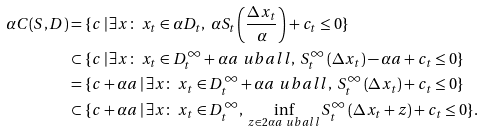<formula> <loc_0><loc_0><loc_500><loc_500>\alpha C ( S , D ) & = \{ c \, | \, \exists x \colon \ x _ { t } \in \alpha D _ { t } , \ \alpha S _ { t } \left ( \frac { \Delta x _ { t } } { \alpha } \right ) + c _ { t } \leq 0 \} \\ & \subset \{ c \, | \, \exists x \colon \ x _ { t } \in D ^ { \infty } _ { t } + \alpha a \ u b a l l , \ S ^ { \infty } _ { t } \left ( \Delta x _ { t } \right ) - \alpha a + c _ { t } \leq 0 \} \\ & = \{ c + \alpha a \, | \, \exists x \colon \ x _ { t } \in D ^ { \infty } _ { t } + \alpha a \ u b a l l , \ S ^ { \infty } _ { t } \left ( \Delta x _ { t } \right ) + c _ { t } \leq 0 \} \\ & \subset \{ c + \alpha a \, | \, \exists x \colon \ x _ { t } \in D ^ { \infty } _ { t } , \ \inf _ { z \in 2 \alpha a \ u b a l l } S ^ { \infty } _ { t } \left ( \Delta x _ { t } + z \right ) + c _ { t } \leq 0 \} .</formula> 